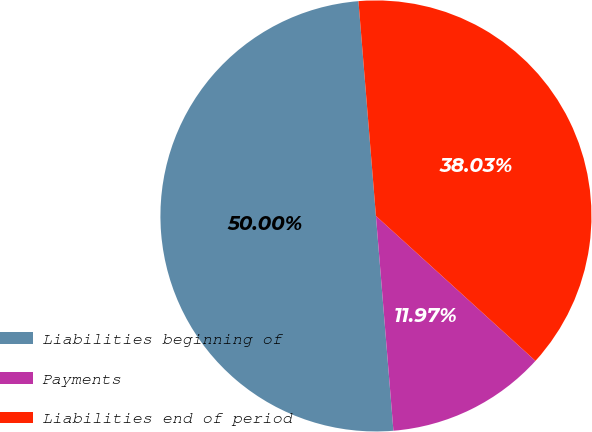Convert chart to OTSL. <chart><loc_0><loc_0><loc_500><loc_500><pie_chart><fcel>Liabilities beginning of<fcel>Payments<fcel>Liabilities end of period<nl><fcel>50.0%<fcel>11.97%<fcel>38.03%<nl></chart> 